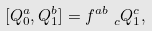<formula> <loc_0><loc_0><loc_500><loc_500>[ Q ^ { a } _ { 0 } , Q ^ { b } _ { 1 } ] = f ^ { a b } _ { \ \ c } Q _ { 1 } ^ { c } ,</formula> 